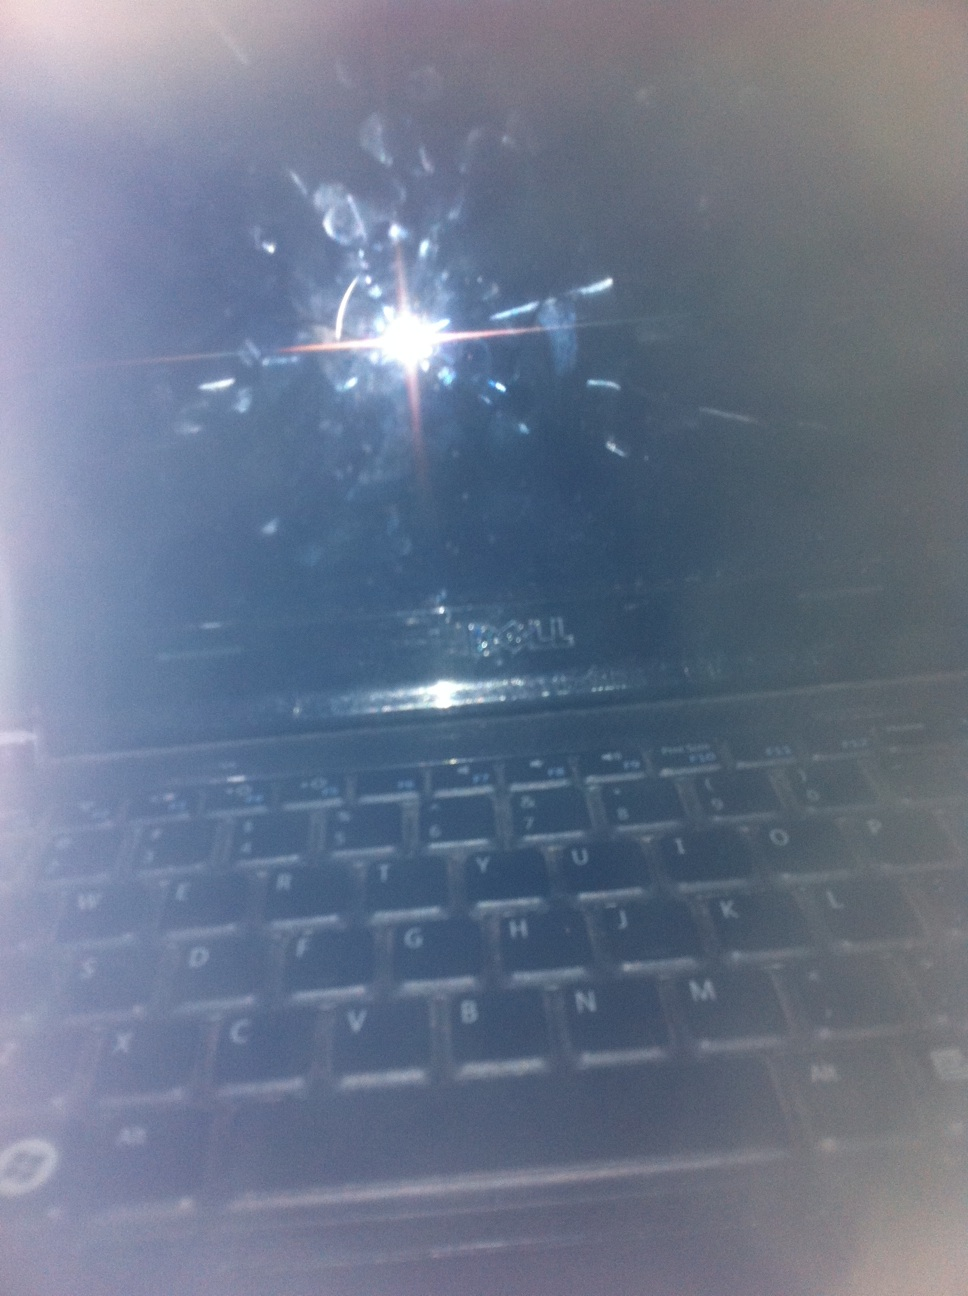Imagine this laptop is part of an alien spaceship. Describe its function and design. This laptop is actually a sophisticated alien navigation device, designed to blend in with human technology. The smudges are biometric interfaces that respond to the touch of the spaceship's crew, allowing them to communicate with the ship's AI directly through touch. This ensures that only authorized users can navigate or access critical systems. The dark screen can display a three-dimensional star map, guiding the spaceship through interstellar space with unmatched precision. 